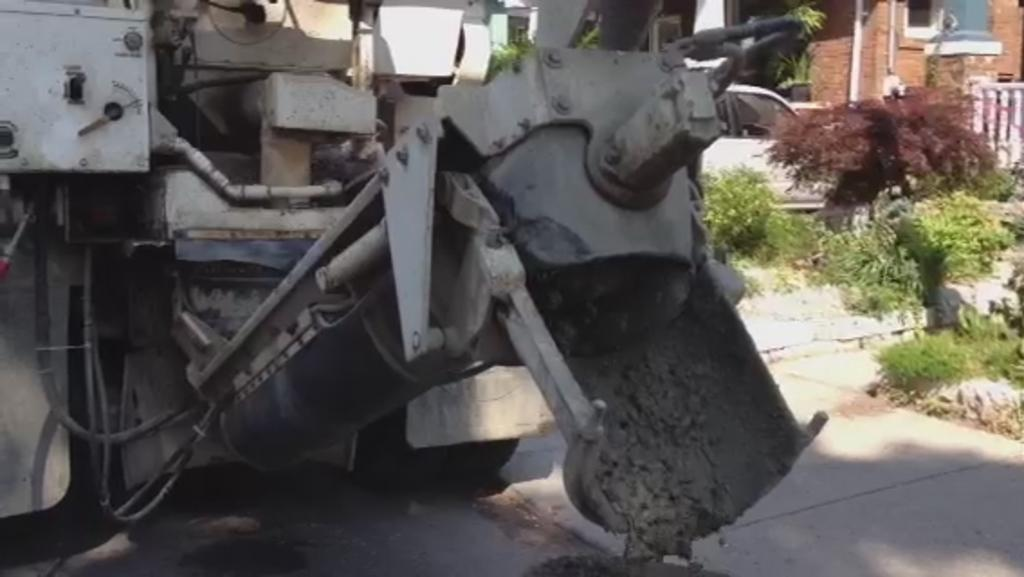What is on the road in the image? There is a vehicle on the road in the image. What material is the road made of? The road is made of concrete. What type of vehicle can be seen in the image? There is a car in the image. What type of vegetation is present in the image? There are plants in the image. What object is associated with the plants? There is a pot in the image. What type of barrier is visible in the image? There is a fence in the image. What man-made object is present in the image? There is a pipe in the image. What architectural feature can be seen in the background of the image? There is a window in the background of the image. What type of structure is visible in the background of the image? There is a wall in the background of the image. What type of behavior is exhibited by the health statement in the image? There is no health statement present in the image. What type of health statement is associated with the behavior of the vehicle in the image? There is no health statement or behavior of the vehicle mentioned in the image. 